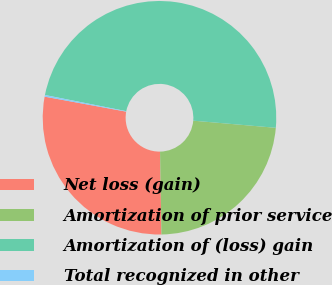Convert chart to OTSL. <chart><loc_0><loc_0><loc_500><loc_500><pie_chart><fcel>Net loss (gain)<fcel>Amortization of prior service<fcel>Amortization of (loss) gain<fcel>Total recognized in other<nl><fcel>28.16%<fcel>23.36%<fcel>48.25%<fcel>0.23%<nl></chart> 